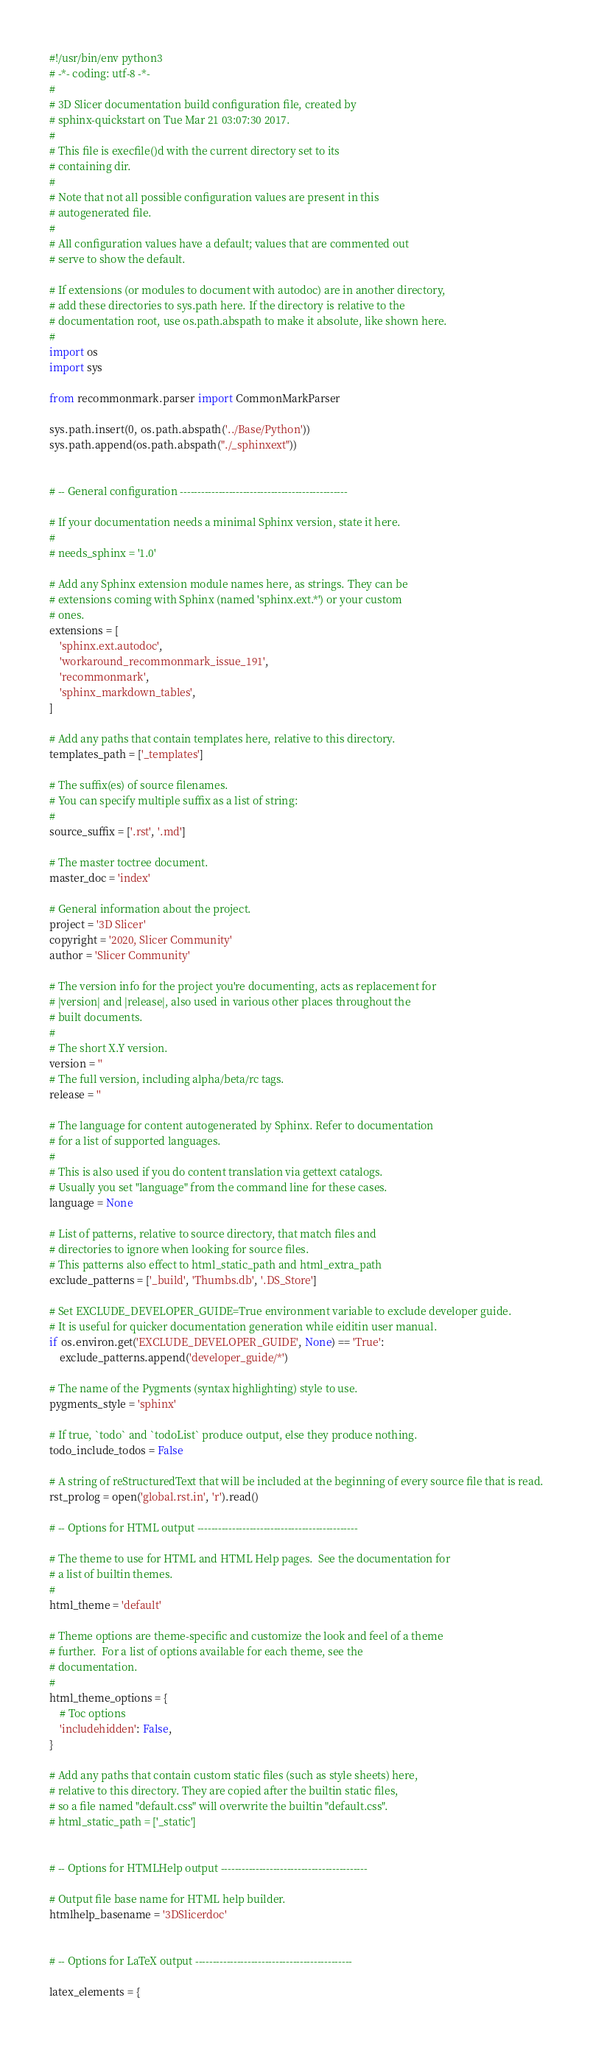Convert code to text. <code><loc_0><loc_0><loc_500><loc_500><_Python_>#!/usr/bin/env python3
# -*- coding: utf-8 -*-
#
# 3D Slicer documentation build configuration file, created by
# sphinx-quickstart on Tue Mar 21 03:07:30 2017.
#
# This file is execfile()d with the current directory set to its
# containing dir.
#
# Note that not all possible configuration values are present in this
# autogenerated file.
#
# All configuration values have a default; values that are commented out
# serve to show the default.

# If extensions (or modules to document with autodoc) are in another directory,
# add these directories to sys.path here. If the directory is relative to the
# documentation root, use os.path.abspath to make it absolute, like shown here.
#
import os
import sys

from recommonmark.parser import CommonMarkParser

sys.path.insert(0, os.path.abspath('../Base/Python'))
sys.path.append(os.path.abspath("./_sphinxext"))


# -- General configuration ------------------------------------------------

# If your documentation needs a minimal Sphinx version, state it here.
#
# needs_sphinx = '1.0'

# Add any Sphinx extension module names here, as strings. They can be
# extensions coming with Sphinx (named 'sphinx.ext.*') or your custom
# ones.
extensions = [
    'sphinx.ext.autodoc',
    'workaround_recommonmark_issue_191',
    'recommonmark',
    'sphinx_markdown_tables',
]

# Add any paths that contain templates here, relative to this directory.
templates_path = ['_templates']

# The suffix(es) of source filenames.
# You can specify multiple suffix as a list of string:
#
source_suffix = ['.rst', '.md']

# The master toctree document.
master_doc = 'index'

# General information about the project.
project = '3D Slicer'
copyright = '2020, Slicer Community'
author = 'Slicer Community'

# The version info for the project you're documenting, acts as replacement for
# |version| and |release|, also used in various other places throughout the
# built documents.
#
# The short X.Y version.
version = ''
# The full version, including alpha/beta/rc tags.
release = ''

# The language for content autogenerated by Sphinx. Refer to documentation
# for a list of supported languages.
#
# This is also used if you do content translation via gettext catalogs.
# Usually you set "language" from the command line for these cases.
language = None

# List of patterns, relative to source directory, that match files and
# directories to ignore when looking for source files.
# This patterns also effect to html_static_path and html_extra_path
exclude_patterns = ['_build', 'Thumbs.db', '.DS_Store']

# Set EXCLUDE_DEVELOPER_GUIDE=True environment variable to exclude developer guide.
# It is useful for quicker documentation generation while eiditin user manual.
if os.environ.get('EXCLUDE_DEVELOPER_GUIDE', None) == 'True':
    exclude_patterns.append('developer_guide/*')

# The name of the Pygments (syntax highlighting) style to use.
pygments_style = 'sphinx'

# If true, `todo` and `todoList` produce output, else they produce nothing.
todo_include_todos = False

# A string of reStructuredText that will be included at the beginning of every source file that is read.
rst_prolog = open('global.rst.in', 'r').read()

# -- Options for HTML output ----------------------------------------------

# The theme to use for HTML and HTML Help pages.  See the documentation for
# a list of builtin themes.
#
html_theme = 'default'

# Theme options are theme-specific and customize the look and feel of a theme
# further.  For a list of options available for each theme, see the
# documentation.
#
html_theme_options = {
    # Toc options
    'includehidden': False,
}

# Add any paths that contain custom static files (such as style sheets) here,
# relative to this directory. They are copied after the builtin static files,
# so a file named "default.css" will overwrite the builtin "default.css".
# html_static_path = ['_static']


# -- Options for HTMLHelp output ------------------------------------------

# Output file base name for HTML help builder.
htmlhelp_basename = '3DSlicerdoc'


# -- Options for LaTeX output ---------------------------------------------

latex_elements = {</code> 